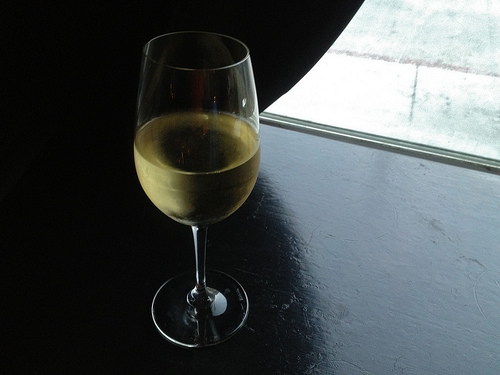<image>
Is there a wine on the table? Yes. Looking at the image, I can see the wine is positioned on top of the table, with the table providing support. Is there a shadow in the table? Yes. The shadow is contained within or inside the table, showing a containment relationship. 